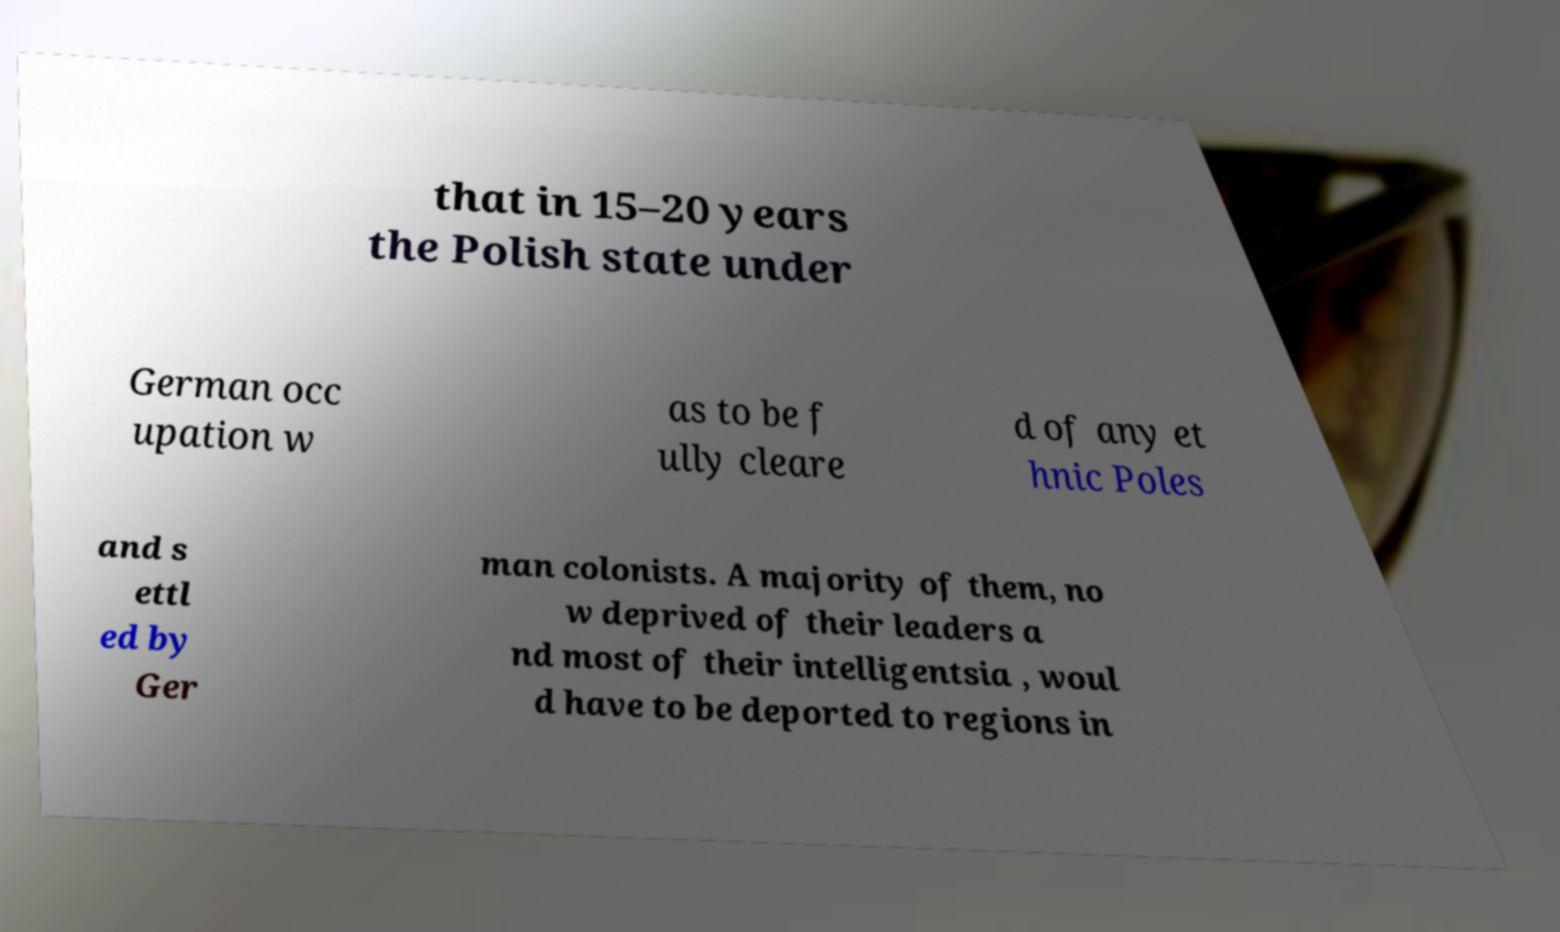Please identify and transcribe the text found in this image. that in 15–20 years the Polish state under German occ upation w as to be f ully cleare d of any et hnic Poles and s ettl ed by Ger man colonists. A majority of them, no w deprived of their leaders a nd most of their intelligentsia , woul d have to be deported to regions in 